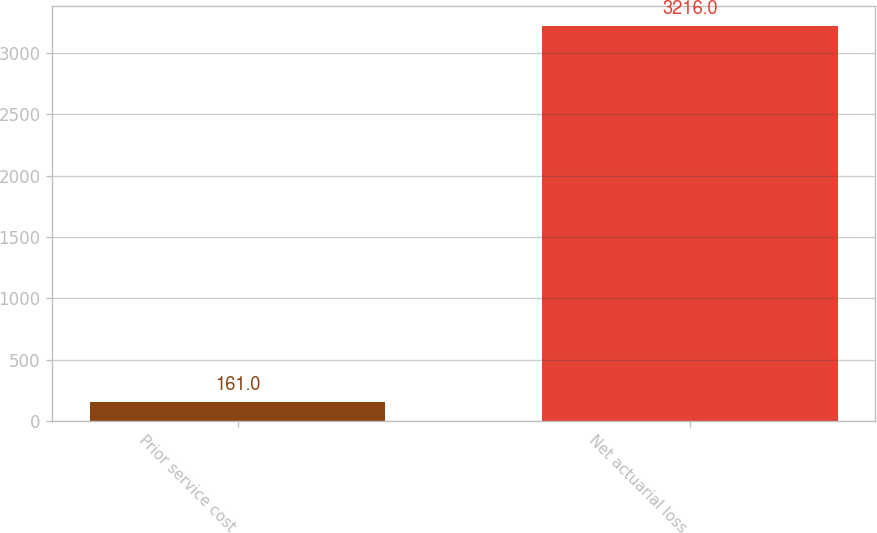<chart> <loc_0><loc_0><loc_500><loc_500><bar_chart><fcel>Prior service cost<fcel>Net actuarial loss<nl><fcel>161<fcel>3216<nl></chart> 